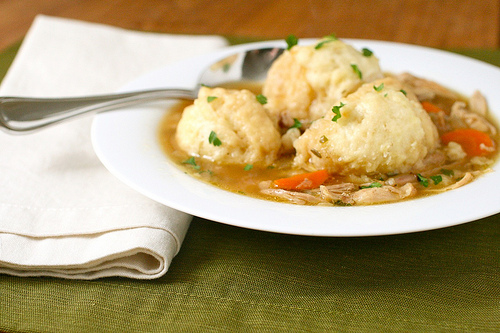<image>
Is there a spoon to the left of the bowl? No. The spoon is not to the left of the bowl. From this viewpoint, they have a different horizontal relationship. 